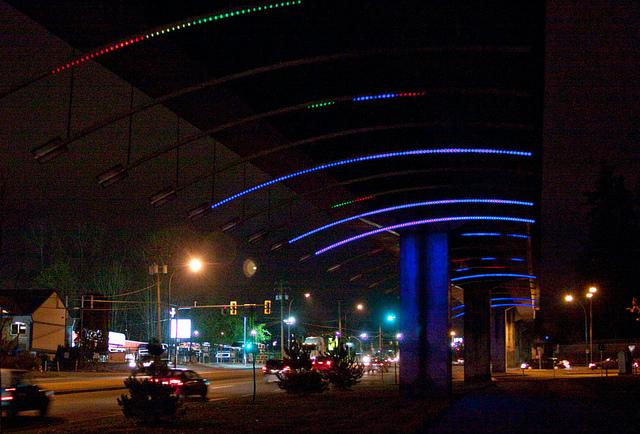The area underneath the structure is illuminated by what? Please explain your reasoning. led lights. The illumination is 90% greater using this method. 